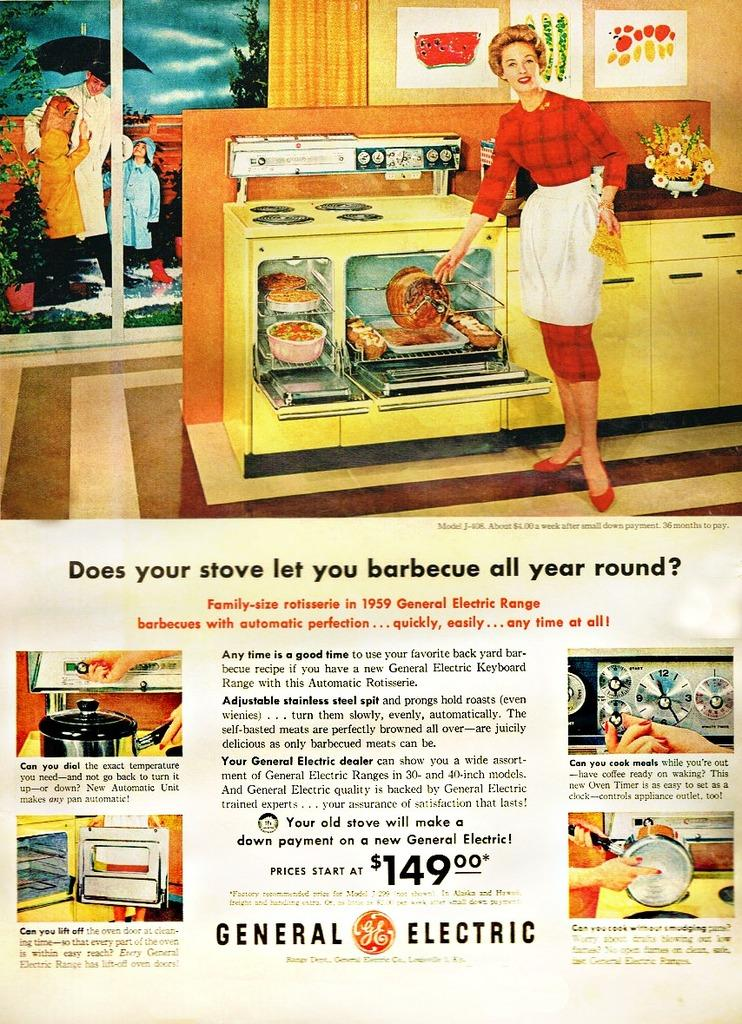<image>
Provide a brief description of the given image. Vintage General Electric advertising featuring yellow kitchen appliances. 